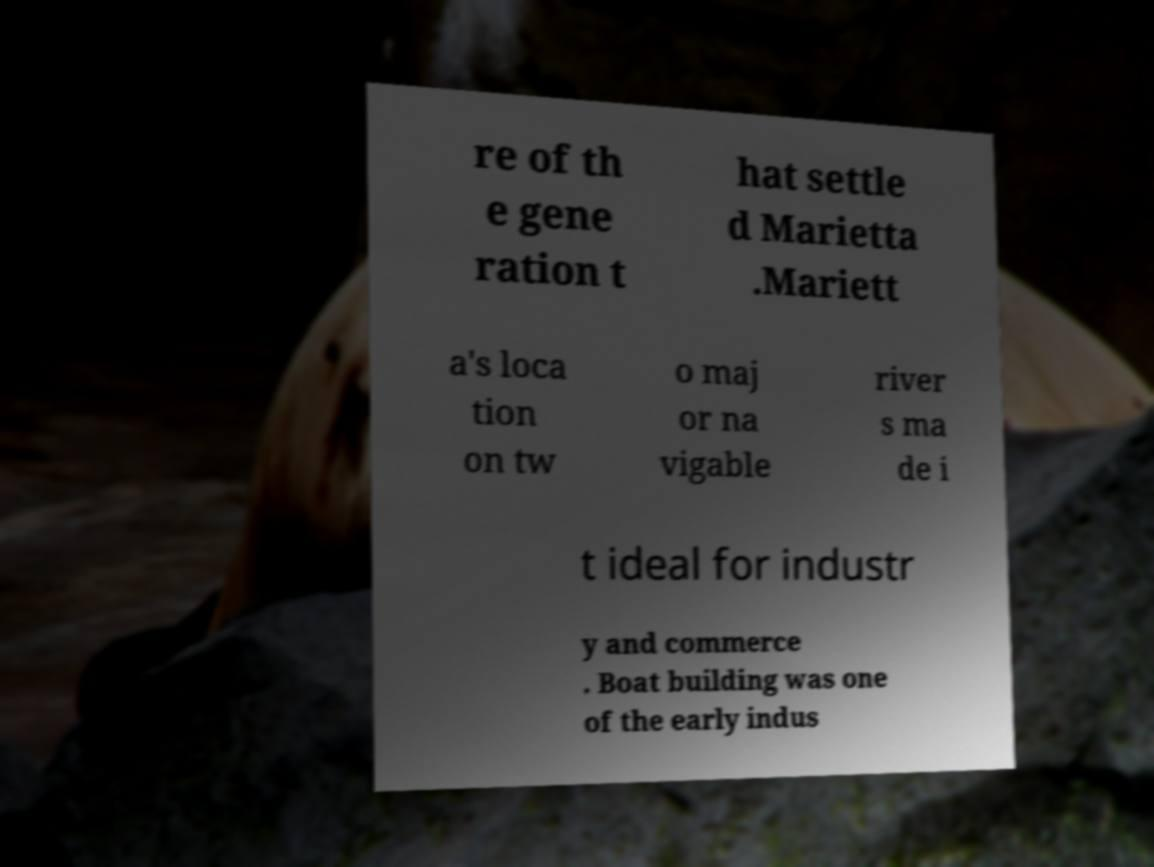Please identify and transcribe the text found in this image. re of th e gene ration t hat settle d Marietta .Mariett a's loca tion on tw o maj or na vigable river s ma de i t ideal for industr y and commerce . Boat building was one of the early indus 